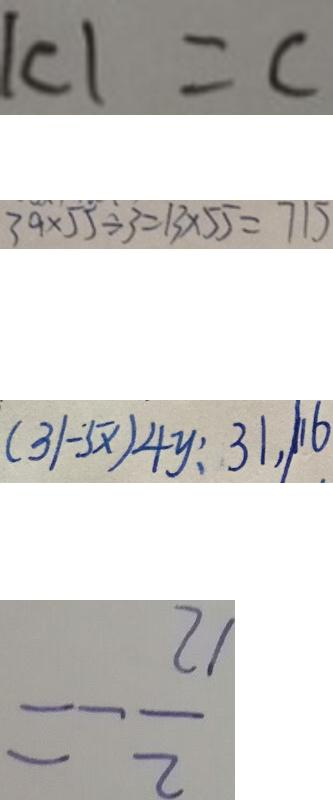<formula> <loc_0><loc_0><loc_500><loc_500>\vert c \vert = c 
 3 9 \times 5 5 \div 3 = 1 3 \times 5 5 = 7 1 5 
 ( 3 1 - 5 x ) 4 y : 3 1 , \vert 1 6 
 = - \frac { 2 1 } { 2 }</formula> 